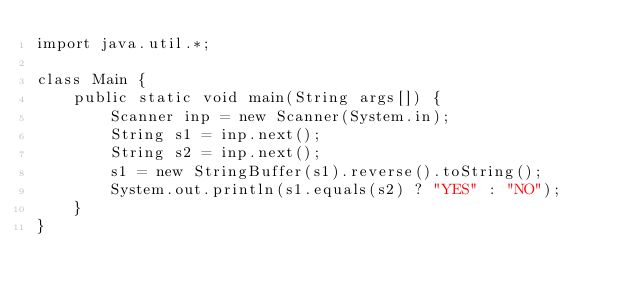Convert code to text. <code><loc_0><loc_0><loc_500><loc_500><_Java_>import java.util.*;

class Main {
    public static void main(String args[]) {
        Scanner inp = new Scanner(System.in);
        String s1 = inp.next();
        String s2 = inp.next();
        s1 = new StringBuffer(s1).reverse().toString();
        System.out.println(s1.equals(s2) ? "YES" : "NO");
    }
}</code> 